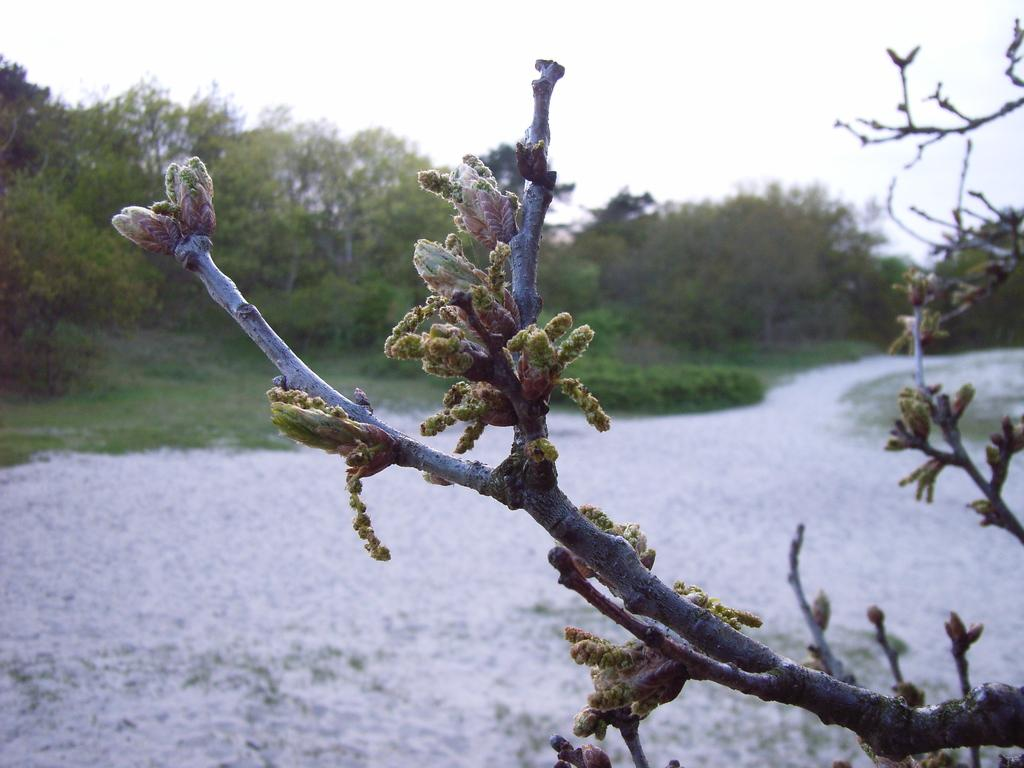What is present in the image? There is a plant in the image. Can you describe the plant? The plant has buds. What can be seen to the left of the image? There are many trees to the left of the image. What is visible in the background of the image? The sky is visible in the background of the image, and it is white. How does the beggar interact with the plant in the image? There is no beggar present in the image, so there is no interaction with the plant. What type of pin can be seen holding the plant's leaves together? There is no pin visible in the image; the plant's leaves are not held together. 